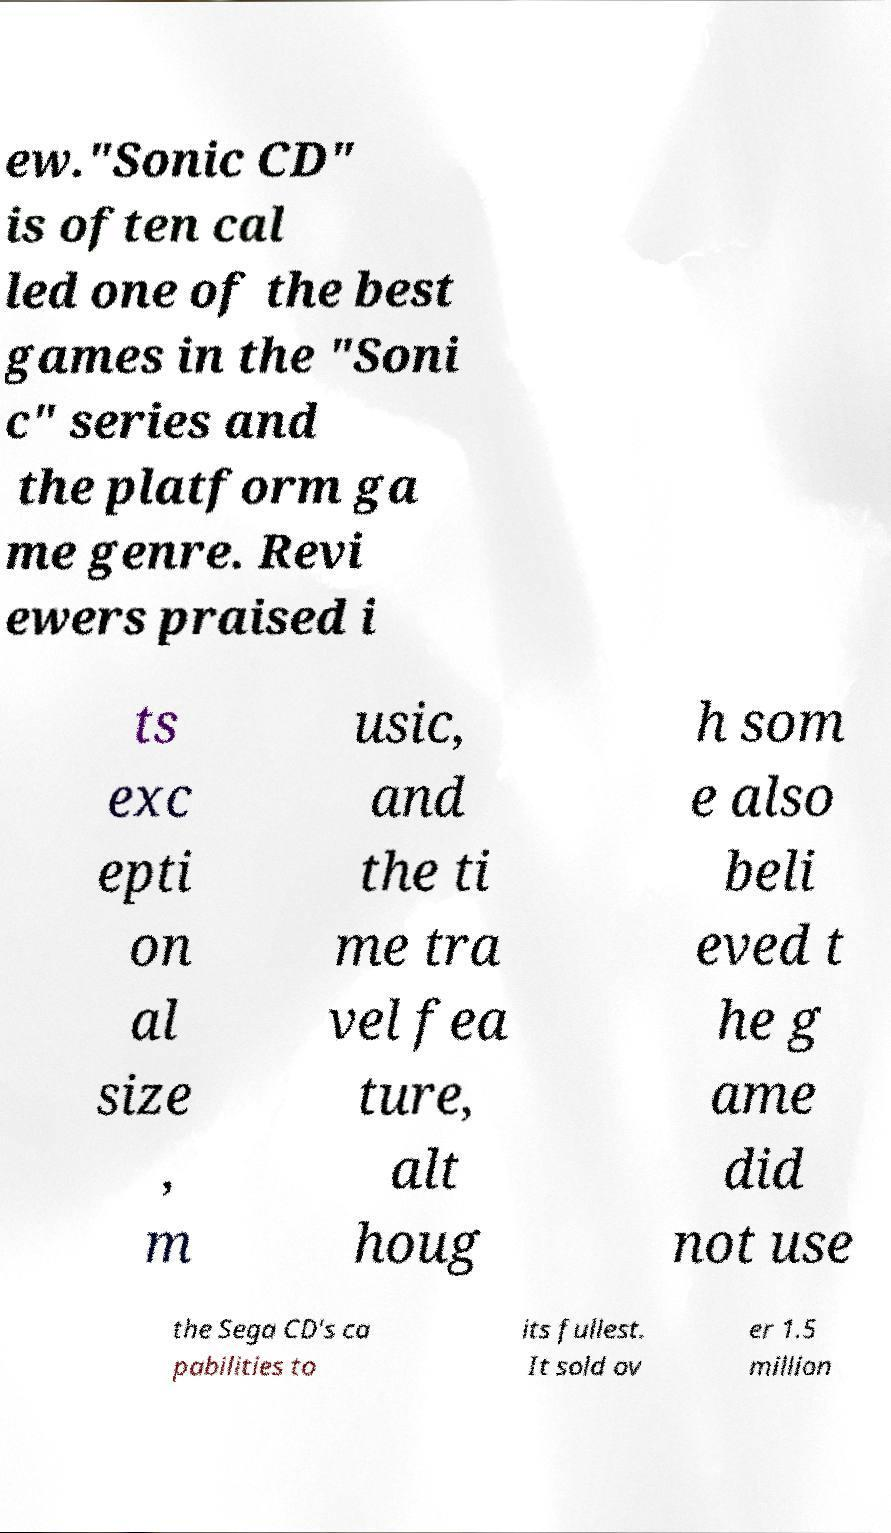Please read and relay the text visible in this image. What does it say? ew."Sonic CD" is often cal led one of the best games in the "Soni c" series and the platform ga me genre. Revi ewers praised i ts exc epti on al size , m usic, and the ti me tra vel fea ture, alt houg h som e also beli eved t he g ame did not use the Sega CD's ca pabilities to its fullest. It sold ov er 1.5 million 